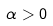Convert formula to latex. <formula><loc_0><loc_0><loc_500><loc_500>\alpha > 0</formula> 